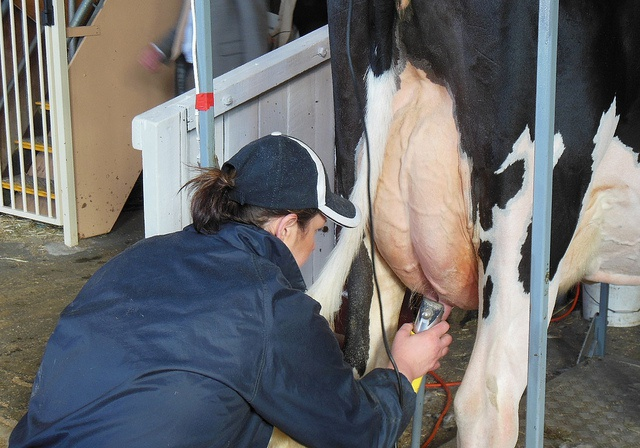Describe the objects in this image and their specific colors. I can see cow in tan, black, and lightgray tones, people in darkgray, darkblue, navy, blue, and black tones, and people in tan, gray, and black tones in this image. 